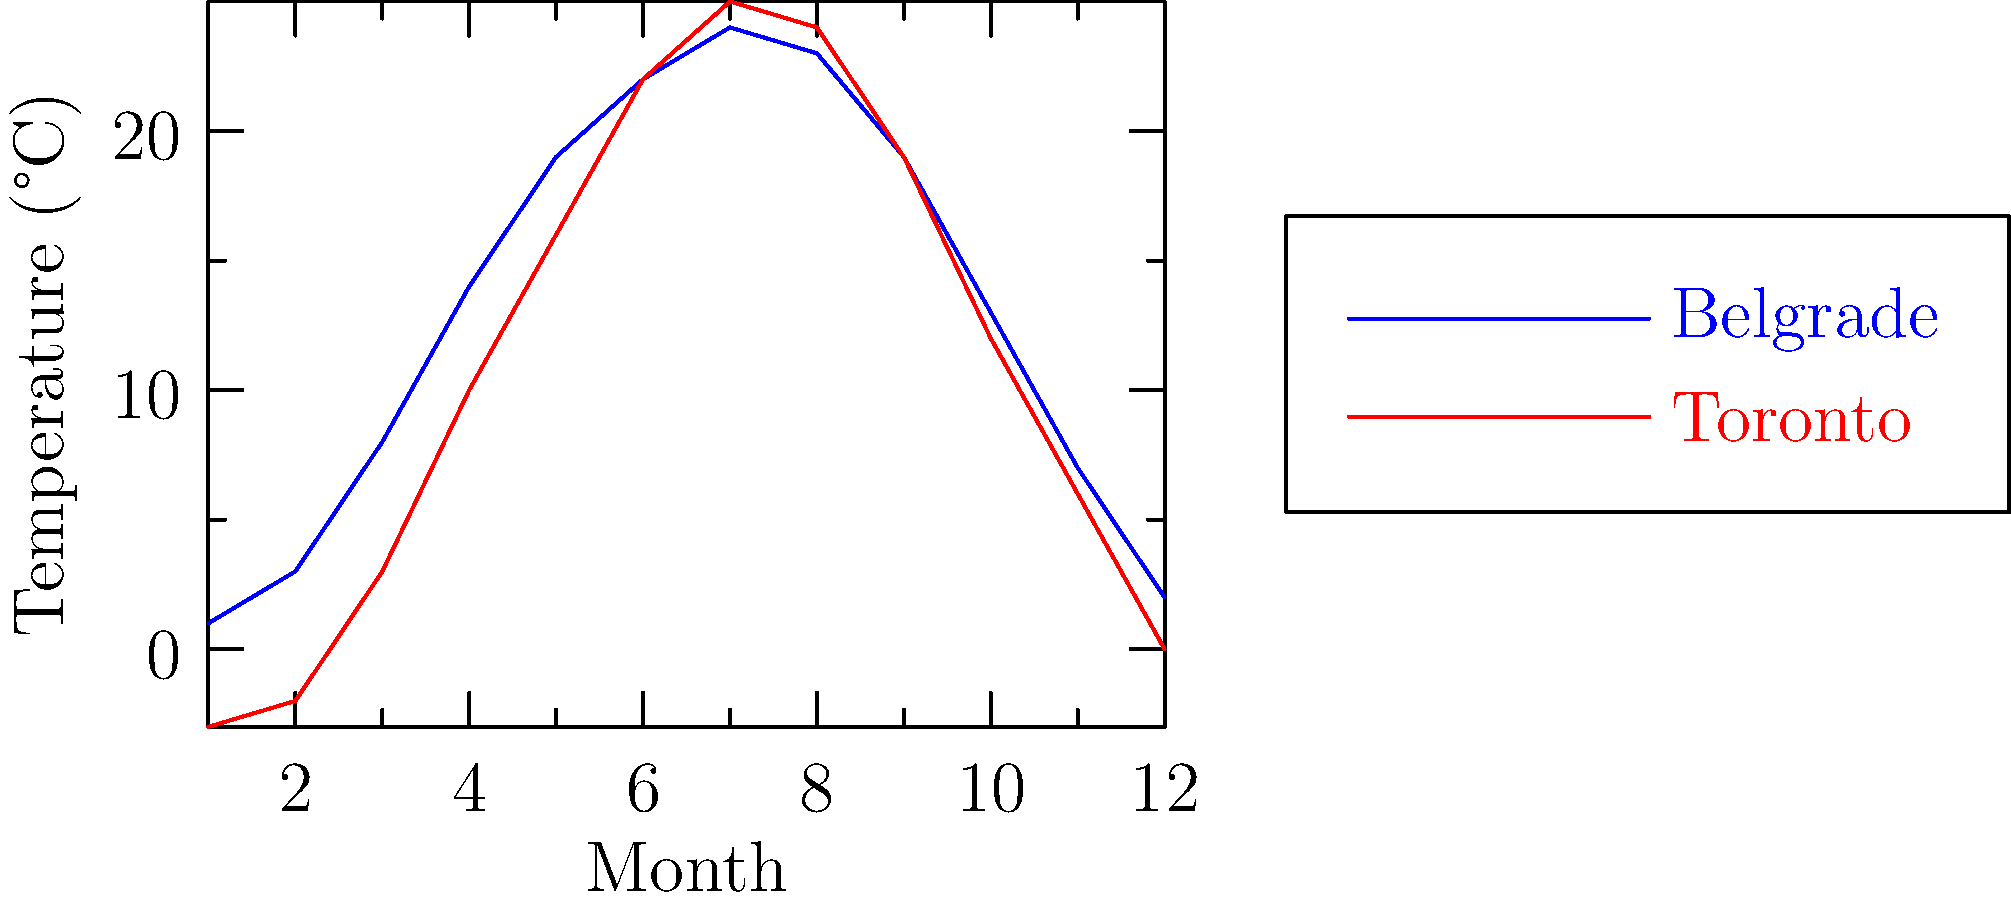The graph shows the average monthly temperatures in Belgrade, Serbia, and Toronto, Canada. In which month is the temperature difference between the two cities the smallest? To find the month with the smallest temperature difference between Belgrade and Toronto:

1. Calculate the difference for each month:
   January: 1 - (-3) = 4°C
   February: 3 - (-2) = 5°C
   March: 8 - 3 = 5°C
   April: 14 - 10 = 4°C
   May: 19 - 16 = 3°C
   June: 22 - 22 = 0°C
   July: 24 - 25 = -1°C
   August: 23 - 24 = -1°C
   September: 19 - 19 = 0°C
   October: 13 - 12 = 1°C
   November: 7 - 6 = 1°C
   December: 2 - 0 = 2°C

2. Identify the smallest absolute difference:
   The smallest difference is 0°C, which occurs in June and September.

3. As the question asks for a single month, we choose the earlier one, which is June.
Answer: June 